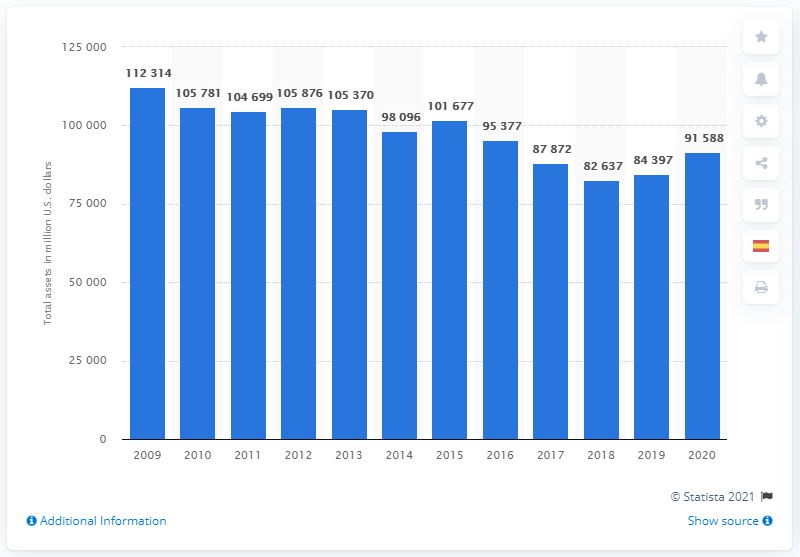List a handful of essential elements in this visual. At the end of 2020, Merck's total assets were 91,588 dollars. 